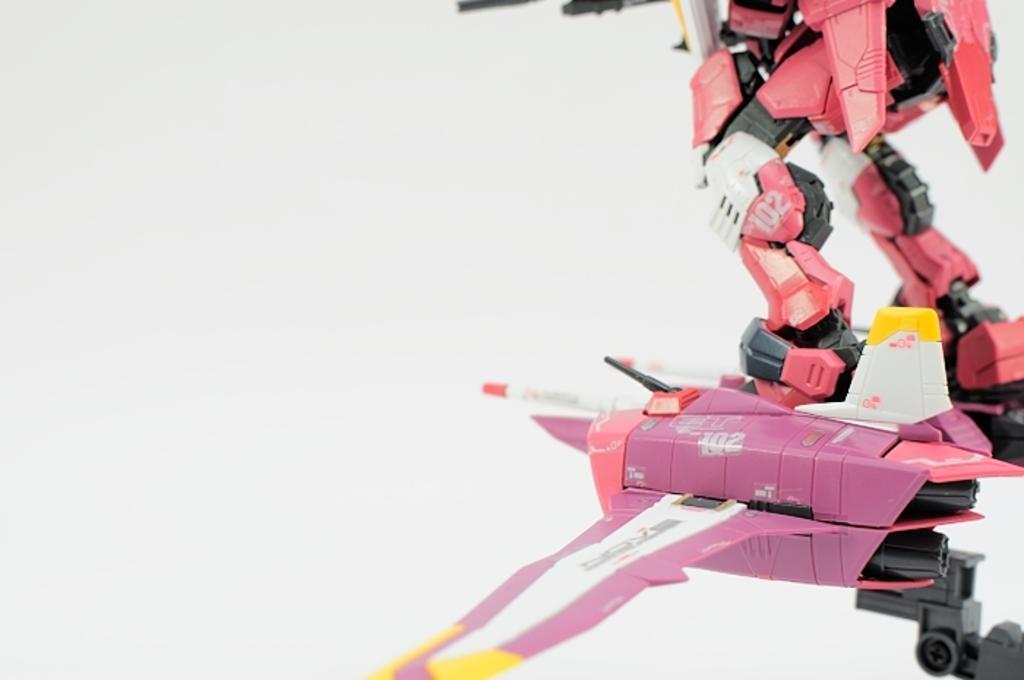Describe this image in one or two sentences. In this image there is a robot at right side of this image and there is a wall in the background. 